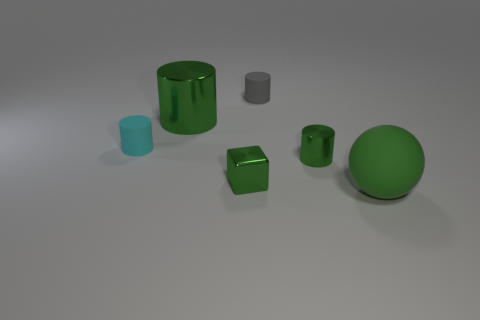How many other things are the same color as the large cylinder?
Your answer should be compact. 3. Is the shiny cube the same color as the big matte thing?
Your answer should be compact. Yes. What size is the ball that is in front of the gray matte object behind the cyan cylinder?
Keep it short and to the point. Large. Is the material of the big green thing left of the large ball the same as the cylinder that is in front of the cyan cylinder?
Keep it short and to the point. Yes. Do the small metal object that is in front of the small green cylinder and the big rubber object have the same color?
Keep it short and to the point. Yes. There is a green rubber ball; how many gray cylinders are behind it?
Your answer should be very brief. 1. Do the small gray object and the tiny cylinder that is on the left side of the tiny green shiny block have the same material?
Give a very brief answer. Yes. There is a green ball that is made of the same material as the tiny gray cylinder; what size is it?
Your answer should be very brief. Large. Are there more green shiny things behind the cyan object than small gray cylinders in front of the green matte thing?
Provide a succinct answer. Yes. Is there a green shiny object of the same shape as the cyan matte thing?
Provide a short and direct response. Yes. 